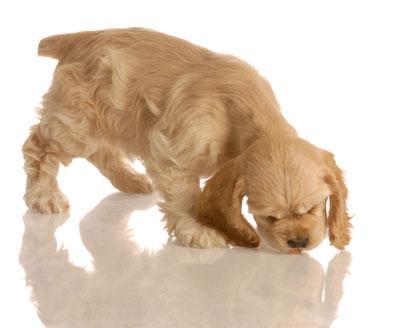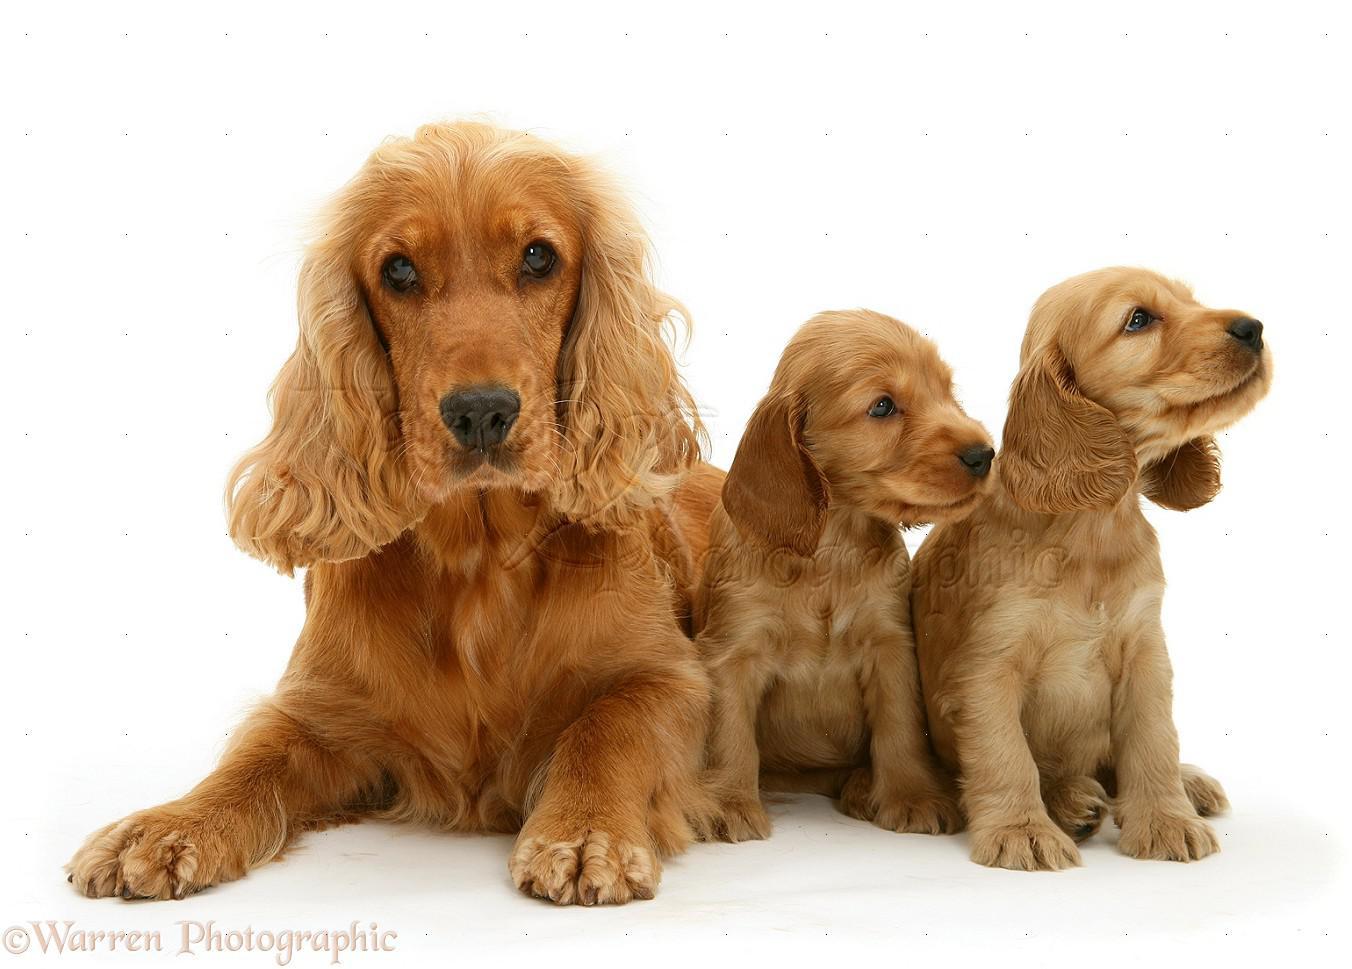The first image is the image on the left, the second image is the image on the right. Analyze the images presented: Is the assertion "An image contains a dog food bowl." valid? Answer yes or no. No. The first image is the image on the left, the second image is the image on the right. Evaluate the accuracy of this statement regarding the images: "An image includes one golden cocker spaniel with its mouth on an orangish food bowl.". Is it true? Answer yes or no. No. 